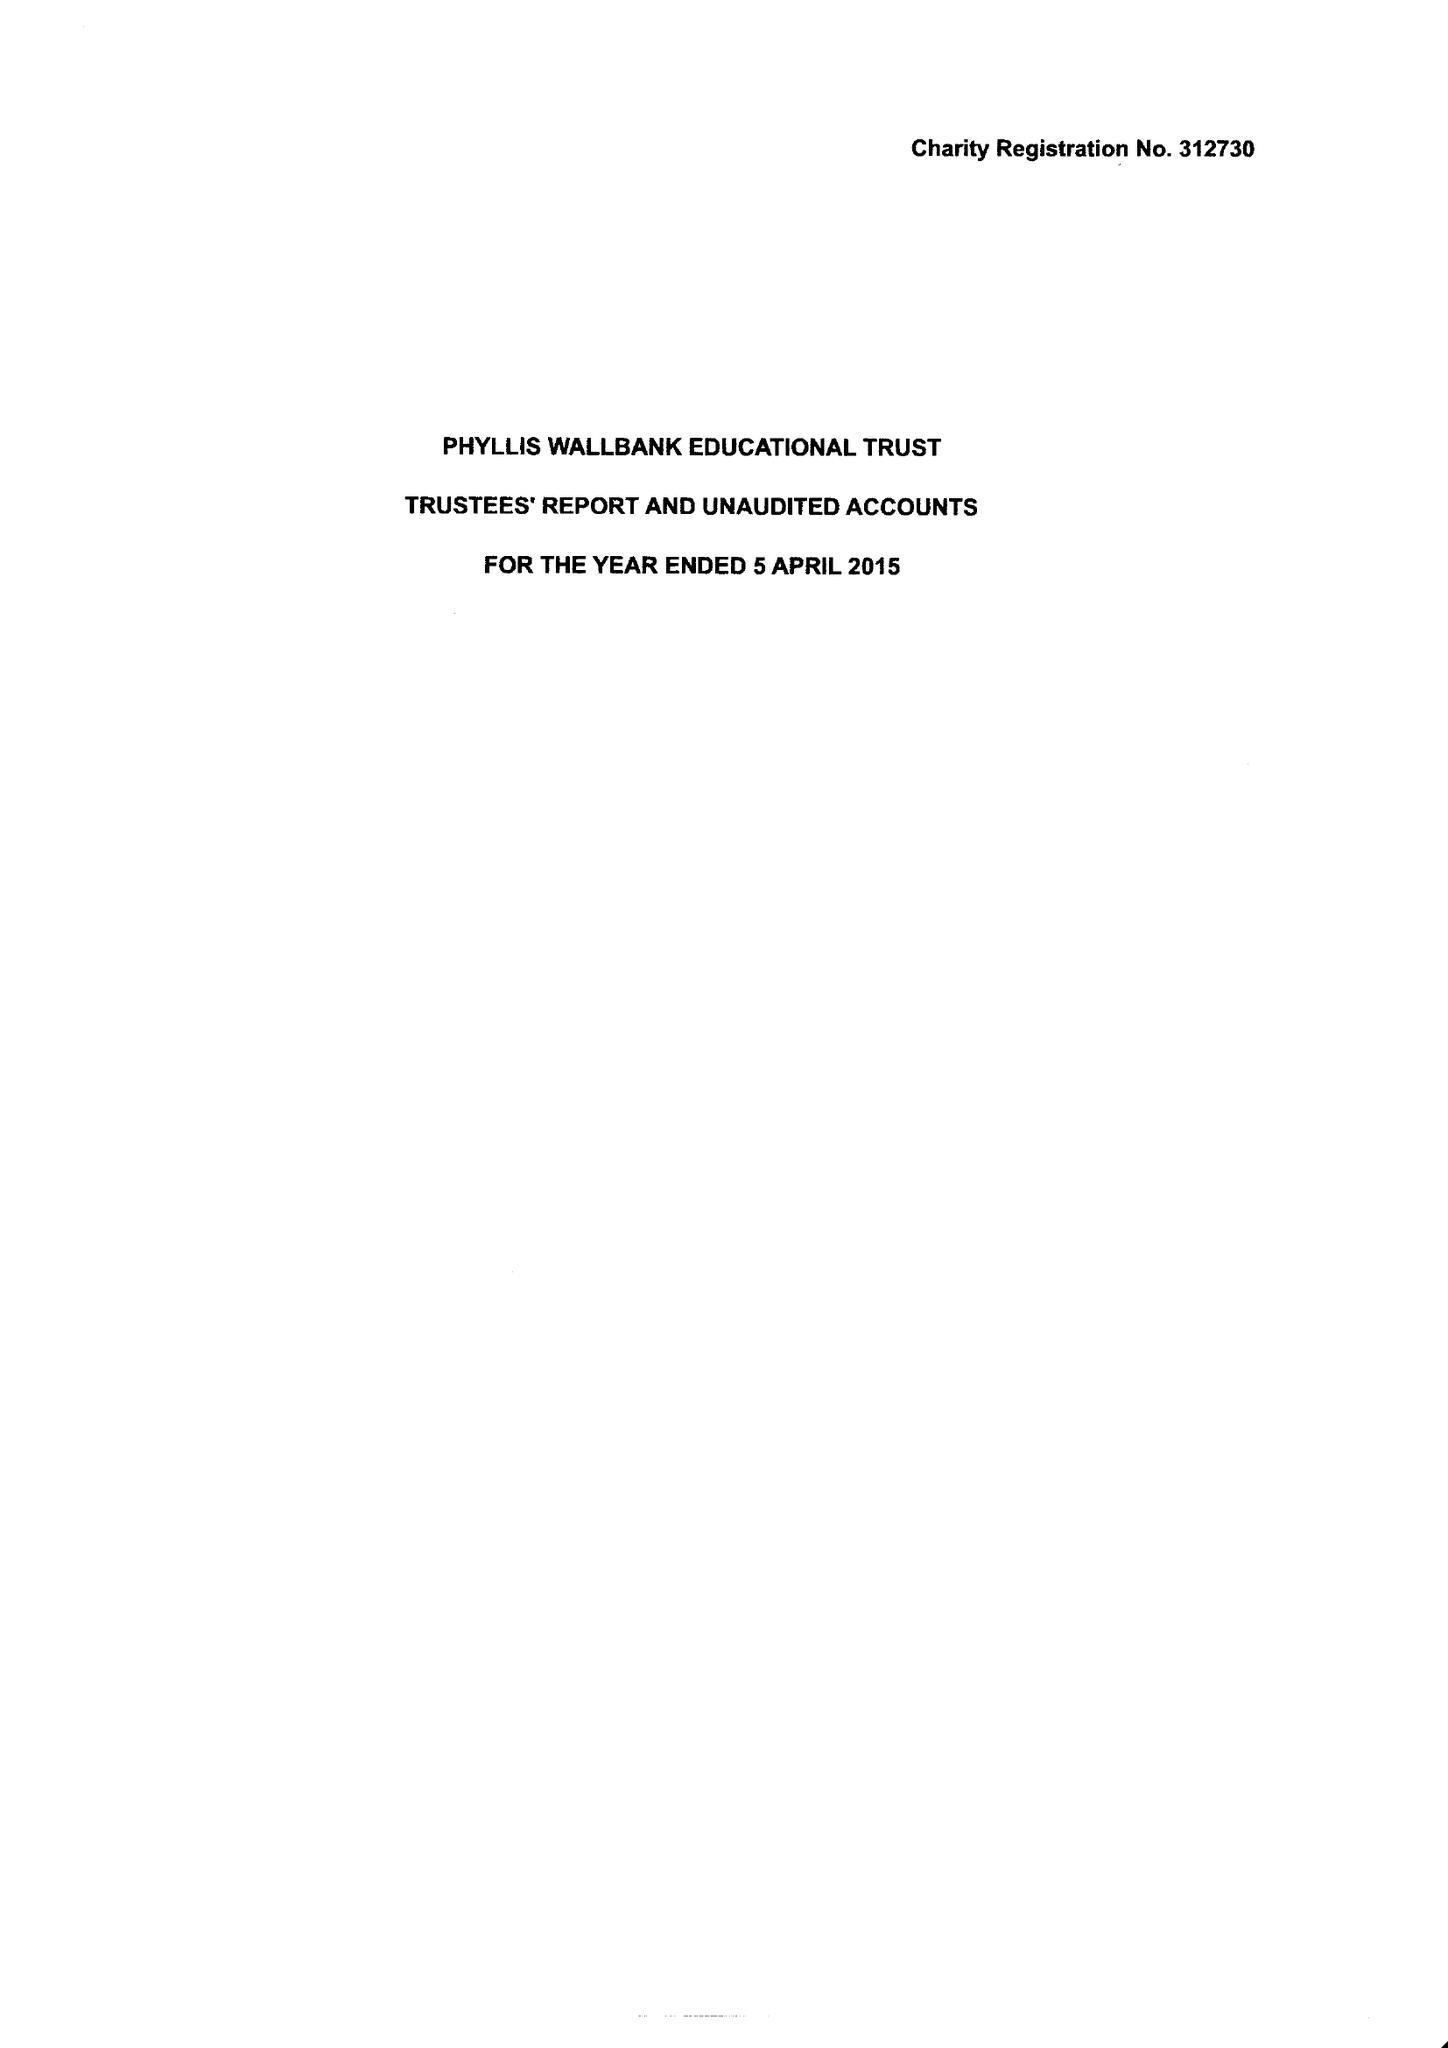What is the value for the charity_name?
Answer the question using a single word or phrase. Phyllis Wallbank Educational Trust 